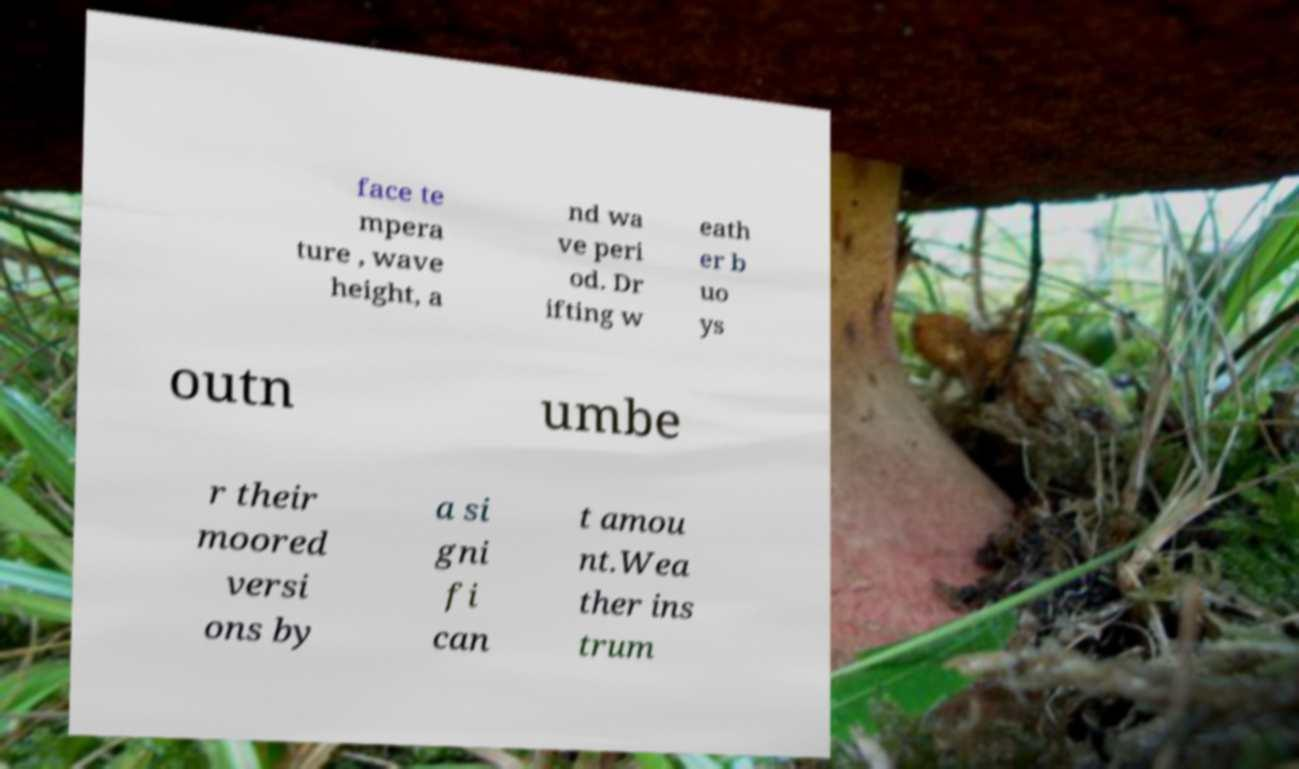Please identify and transcribe the text found in this image. face te mpera ture , wave height, a nd wa ve peri od. Dr ifting w eath er b uo ys outn umbe r their moored versi ons by a si gni fi can t amou nt.Wea ther ins trum 